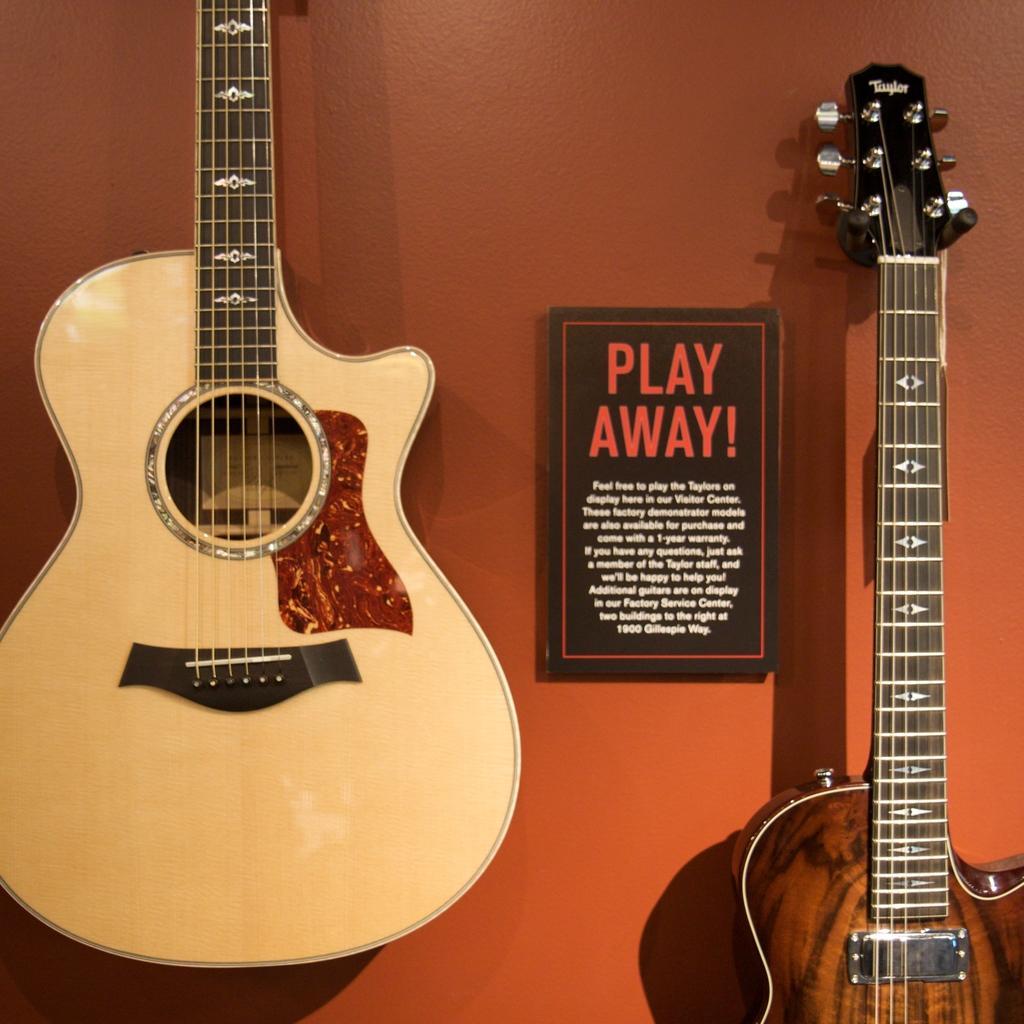In one or two sentences, can you explain what this image depicts? In this picture we can see two guitars. And there is a board on to the wall. And on the background there is a orange color wall. 